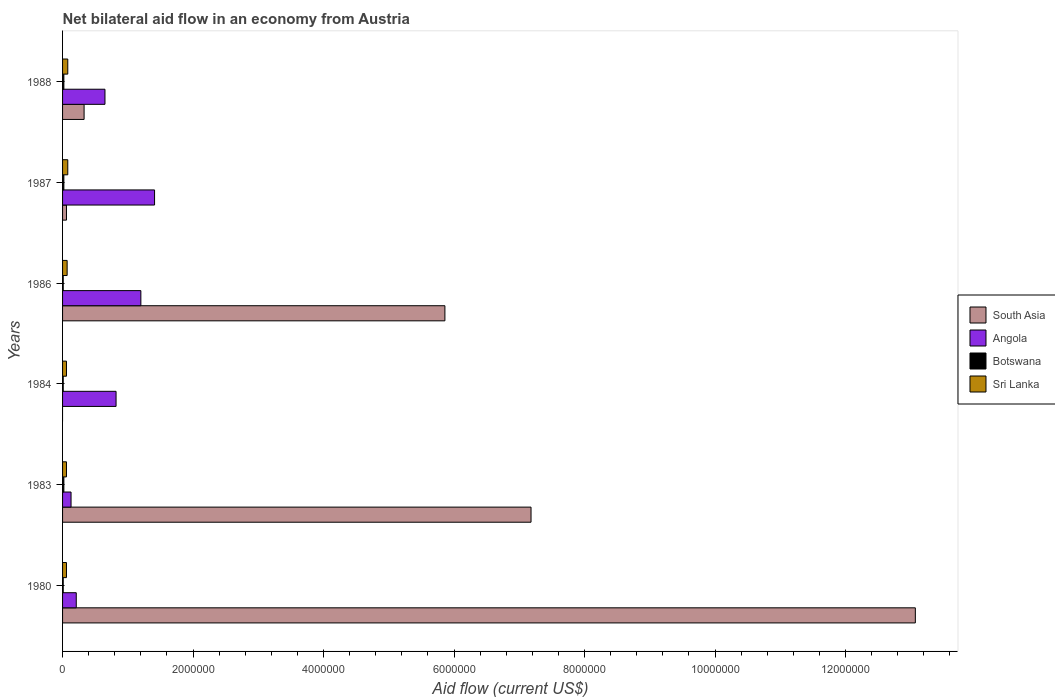How many different coloured bars are there?
Your answer should be very brief. 4. How many groups of bars are there?
Your answer should be compact. 6. Are the number of bars per tick equal to the number of legend labels?
Provide a succinct answer. No. How many bars are there on the 4th tick from the top?
Keep it short and to the point. 3. How many bars are there on the 1st tick from the bottom?
Offer a very short reply. 4. In how many cases, is the number of bars for a given year not equal to the number of legend labels?
Offer a terse response. 1. What is the net bilateral aid flow in Angola in 1984?
Provide a short and direct response. 8.20e+05. Across all years, what is the maximum net bilateral aid flow in Sri Lanka?
Provide a succinct answer. 8.00e+04. Across all years, what is the minimum net bilateral aid flow in South Asia?
Offer a terse response. 0. What is the total net bilateral aid flow in Angola in the graph?
Offer a very short reply. 4.42e+06. What is the difference between the net bilateral aid flow in South Asia in 1980 and that in 1986?
Your response must be concise. 7.21e+06. What is the difference between the net bilateral aid flow in Botswana in 1984 and the net bilateral aid flow in Angola in 1986?
Offer a terse response. -1.19e+06. What is the average net bilateral aid flow in Botswana per year?
Ensure brevity in your answer.  1.50e+04. In the year 1987, what is the difference between the net bilateral aid flow in Botswana and net bilateral aid flow in South Asia?
Provide a succinct answer. -4.00e+04. What is the ratio of the net bilateral aid flow in South Asia in 1983 to that in 1986?
Give a very brief answer. 1.23. What is the difference between the highest and the lowest net bilateral aid flow in South Asia?
Offer a terse response. 1.31e+07. Is it the case that in every year, the sum of the net bilateral aid flow in Angola and net bilateral aid flow in Botswana is greater than the sum of net bilateral aid flow in Sri Lanka and net bilateral aid flow in South Asia?
Your answer should be very brief. No. How many bars are there?
Give a very brief answer. 23. Are the values on the major ticks of X-axis written in scientific E-notation?
Provide a succinct answer. No. How are the legend labels stacked?
Provide a short and direct response. Vertical. What is the title of the graph?
Make the answer very short. Net bilateral aid flow in an economy from Austria. Does "OECD members" appear as one of the legend labels in the graph?
Give a very brief answer. No. What is the Aid flow (current US$) of South Asia in 1980?
Your answer should be very brief. 1.31e+07. What is the Aid flow (current US$) of Angola in 1980?
Your answer should be very brief. 2.10e+05. What is the Aid flow (current US$) in Sri Lanka in 1980?
Provide a short and direct response. 6.00e+04. What is the Aid flow (current US$) of South Asia in 1983?
Provide a succinct answer. 7.18e+06. What is the Aid flow (current US$) in South Asia in 1984?
Offer a very short reply. 0. What is the Aid flow (current US$) in Angola in 1984?
Your answer should be very brief. 8.20e+05. What is the Aid flow (current US$) in South Asia in 1986?
Provide a succinct answer. 5.86e+06. What is the Aid flow (current US$) in Angola in 1986?
Provide a succinct answer. 1.20e+06. What is the Aid flow (current US$) in Botswana in 1986?
Provide a succinct answer. 10000. What is the Aid flow (current US$) in South Asia in 1987?
Keep it short and to the point. 6.00e+04. What is the Aid flow (current US$) of Angola in 1987?
Your answer should be compact. 1.41e+06. What is the Aid flow (current US$) in Botswana in 1987?
Provide a succinct answer. 2.00e+04. What is the Aid flow (current US$) of Sri Lanka in 1987?
Give a very brief answer. 8.00e+04. What is the Aid flow (current US$) in South Asia in 1988?
Keep it short and to the point. 3.30e+05. What is the Aid flow (current US$) in Angola in 1988?
Keep it short and to the point. 6.50e+05. What is the Aid flow (current US$) of Botswana in 1988?
Offer a terse response. 2.00e+04. Across all years, what is the maximum Aid flow (current US$) of South Asia?
Provide a succinct answer. 1.31e+07. Across all years, what is the maximum Aid flow (current US$) of Angola?
Your answer should be very brief. 1.41e+06. Across all years, what is the maximum Aid flow (current US$) in Botswana?
Provide a succinct answer. 2.00e+04. Across all years, what is the maximum Aid flow (current US$) of Sri Lanka?
Offer a terse response. 8.00e+04. Across all years, what is the minimum Aid flow (current US$) of Botswana?
Keep it short and to the point. 10000. What is the total Aid flow (current US$) in South Asia in the graph?
Ensure brevity in your answer.  2.65e+07. What is the total Aid flow (current US$) in Angola in the graph?
Your response must be concise. 4.42e+06. What is the total Aid flow (current US$) of Botswana in the graph?
Offer a terse response. 9.00e+04. What is the difference between the Aid flow (current US$) of South Asia in 1980 and that in 1983?
Your response must be concise. 5.89e+06. What is the difference between the Aid flow (current US$) in Sri Lanka in 1980 and that in 1983?
Ensure brevity in your answer.  0. What is the difference between the Aid flow (current US$) of Angola in 1980 and that in 1984?
Offer a terse response. -6.10e+05. What is the difference between the Aid flow (current US$) in Sri Lanka in 1980 and that in 1984?
Ensure brevity in your answer.  0. What is the difference between the Aid flow (current US$) in South Asia in 1980 and that in 1986?
Provide a succinct answer. 7.21e+06. What is the difference between the Aid flow (current US$) in Angola in 1980 and that in 1986?
Your response must be concise. -9.90e+05. What is the difference between the Aid flow (current US$) of Sri Lanka in 1980 and that in 1986?
Your answer should be very brief. -10000. What is the difference between the Aid flow (current US$) of South Asia in 1980 and that in 1987?
Ensure brevity in your answer.  1.30e+07. What is the difference between the Aid flow (current US$) of Angola in 1980 and that in 1987?
Provide a succinct answer. -1.20e+06. What is the difference between the Aid flow (current US$) in Sri Lanka in 1980 and that in 1987?
Ensure brevity in your answer.  -2.00e+04. What is the difference between the Aid flow (current US$) of South Asia in 1980 and that in 1988?
Offer a terse response. 1.27e+07. What is the difference between the Aid flow (current US$) in Angola in 1980 and that in 1988?
Offer a very short reply. -4.40e+05. What is the difference between the Aid flow (current US$) of Botswana in 1980 and that in 1988?
Your answer should be very brief. -10000. What is the difference between the Aid flow (current US$) in Angola in 1983 and that in 1984?
Provide a succinct answer. -6.90e+05. What is the difference between the Aid flow (current US$) of Sri Lanka in 1983 and that in 1984?
Give a very brief answer. 0. What is the difference between the Aid flow (current US$) of South Asia in 1983 and that in 1986?
Make the answer very short. 1.32e+06. What is the difference between the Aid flow (current US$) of Angola in 1983 and that in 1986?
Offer a terse response. -1.07e+06. What is the difference between the Aid flow (current US$) in Botswana in 1983 and that in 1986?
Your response must be concise. 10000. What is the difference between the Aid flow (current US$) in Sri Lanka in 1983 and that in 1986?
Provide a short and direct response. -10000. What is the difference between the Aid flow (current US$) in South Asia in 1983 and that in 1987?
Provide a succinct answer. 7.12e+06. What is the difference between the Aid flow (current US$) of Angola in 1983 and that in 1987?
Provide a short and direct response. -1.28e+06. What is the difference between the Aid flow (current US$) of South Asia in 1983 and that in 1988?
Provide a succinct answer. 6.85e+06. What is the difference between the Aid flow (current US$) in Angola in 1983 and that in 1988?
Provide a succinct answer. -5.20e+05. What is the difference between the Aid flow (current US$) of Sri Lanka in 1983 and that in 1988?
Provide a succinct answer. -2.00e+04. What is the difference between the Aid flow (current US$) of Angola in 1984 and that in 1986?
Keep it short and to the point. -3.80e+05. What is the difference between the Aid flow (current US$) in Botswana in 1984 and that in 1986?
Give a very brief answer. 0. What is the difference between the Aid flow (current US$) in Angola in 1984 and that in 1987?
Provide a succinct answer. -5.90e+05. What is the difference between the Aid flow (current US$) in Botswana in 1984 and that in 1988?
Your answer should be compact. -10000. What is the difference between the Aid flow (current US$) of South Asia in 1986 and that in 1987?
Your answer should be very brief. 5.80e+06. What is the difference between the Aid flow (current US$) in Botswana in 1986 and that in 1987?
Ensure brevity in your answer.  -10000. What is the difference between the Aid flow (current US$) of South Asia in 1986 and that in 1988?
Offer a terse response. 5.53e+06. What is the difference between the Aid flow (current US$) of Angola in 1986 and that in 1988?
Ensure brevity in your answer.  5.50e+05. What is the difference between the Aid flow (current US$) of Botswana in 1986 and that in 1988?
Provide a succinct answer. -10000. What is the difference between the Aid flow (current US$) in Sri Lanka in 1986 and that in 1988?
Your answer should be compact. -10000. What is the difference between the Aid flow (current US$) in South Asia in 1987 and that in 1988?
Ensure brevity in your answer.  -2.70e+05. What is the difference between the Aid flow (current US$) in Angola in 1987 and that in 1988?
Your response must be concise. 7.60e+05. What is the difference between the Aid flow (current US$) of Sri Lanka in 1987 and that in 1988?
Your answer should be compact. 0. What is the difference between the Aid flow (current US$) of South Asia in 1980 and the Aid flow (current US$) of Angola in 1983?
Your response must be concise. 1.29e+07. What is the difference between the Aid flow (current US$) of South Asia in 1980 and the Aid flow (current US$) of Botswana in 1983?
Make the answer very short. 1.30e+07. What is the difference between the Aid flow (current US$) of South Asia in 1980 and the Aid flow (current US$) of Sri Lanka in 1983?
Your response must be concise. 1.30e+07. What is the difference between the Aid flow (current US$) of Angola in 1980 and the Aid flow (current US$) of Sri Lanka in 1983?
Your answer should be compact. 1.50e+05. What is the difference between the Aid flow (current US$) in South Asia in 1980 and the Aid flow (current US$) in Angola in 1984?
Your answer should be compact. 1.22e+07. What is the difference between the Aid flow (current US$) in South Asia in 1980 and the Aid flow (current US$) in Botswana in 1984?
Your answer should be very brief. 1.31e+07. What is the difference between the Aid flow (current US$) of South Asia in 1980 and the Aid flow (current US$) of Sri Lanka in 1984?
Ensure brevity in your answer.  1.30e+07. What is the difference between the Aid flow (current US$) in Angola in 1980 and the Aid flow (current US$) in Botswana in 1984?
Offer a very short reply. 2.00e+05. What is the difference between the Aid flow (current US$) of Angola in 1980 and the Aid flow (current US$) of Sri Lanka in 1984?
Provide a succinct answer. 1.50e+05. What is the difference between the Aid flow (current US$) of Botswana in 1980 and the Aid flow (current US$) of Sri Lanka in 1984?
Keep it short and to the point. -5.00e+04. What is the difference between the Aid flow (current US$) of South Asia in 1980 and the Aid flow (current US$) of Angola in 1986?
Provide a succinct answer. 1.19e+07. What is the difference between the Aid flow (current US$) in South Asia in 1980 and the Aid flow (current US$) in Botswana in 1986?
Give a very brief answer. 1.31e+07. What is the difference between the Aid flow (current US$) in South Asia in 1980 and the Aid flow (current US$) in Sri Lanka in 1986?
Provide a succinct answer. 1.30e+07. What is the difference between the Aid flow (current US$) of Botswana in 1980 and the Aid flow (current US$) of Sri Lanka in 1986?
Your response must be concise. -6.00e+04. What is the difference between the Aid flow (current US$) in South Asia in 1980 and the Aid flow (current US$) in Angola in 1987?
Your answer should be very brief. 1.17e+07. What is the difference between the Aid flow (current US$) of South Asia in 1980 and the Aid flow (current US$) of Botswana in 1987?
Give a very brief answer. 1.30e+07. What is the difference between the Aid flow (current US$) in South Asia in 1980 and the Aid flow (current US$) in Sri Lanka in 1987?
Provide a short and direct response. 1.30e+07. What is the difference between the Aid flow (current US$) of Angola in 1980 and the Aid flow (current US$) of Sri Lanka in 1987?
Keep it short and to the point. 1.30e+05. What is the difference between the Aid flow (current US$) in South Asia in 1980 and the Aid flow (current US$) in Angola in 1988?
Offer a terse response. 1.24e+07. What is the difference between the Aid flow (current US$) in South Asia in 1980 and the Aid flow (current US$) in Botswana in 1988?
Offer a very short reply. 1.30e+07. What is the difference between the Aid flow (current US$) of South Asia in 1980 and the Aid flow (current US$) of Sri Lanka in 1988?
Provide a succinct answer. 1.30e+07. What is the difference between the Aid flow (current US$) in Angola in 1980 and the Aid flow (current US$) in Botswana in 1988?
Provide a short and direct response. 1.90e+05. What is the difference between the Aid flow (current US$) in South Asia in 1983 and the Aid flow (current US$) in Angola in 1984?
Keep it short and to the point. 6.36e+06. What is the difference between the Aid flow (current US$) of South Asia in 1983 and the Aid flow (current US$) of Botswana in 1984?
Your answer should be very brief. 7.17e+06. What is the difference between the Aid flow (current US$) of South Asia in 1983 and the Aid flow (current US$) of Sri Lanka in 1984?
Provide a succinct answer. 7.12e+06. What is the difference between the Aid flow (current US$) of Angola in 1983 and the Aid flow (current US$) of Botswana in 1984?
Provide a short and direct response. 1.20e+05. What is the difference between the Aid flow (current US$) of Angola in 1983 and the Aid flow (current US$) of Sri Lanka in 1984?
Give a very brief answer. 7.00e+04. What is the difference between the Aid flow (current US$) of Botswana in 1983 and the Aid flow (current US$) of Sri Lanka in 1984?
Keep it short and to the point. -4.00e+04. What is the difference between the Aid flow (current US$) of South Asia in 1983 and the Aid flow (current US$) of Angola in 1986?
Provide a short and direct response. 5.98e+06. What is the difference between the Aid flow (current US$) in South Asia in 1983 and the Aid flow (current US$) in Botswana in 1986?
Keep it short and to the point. 7.17e+06. What is the difference between the Aid flow (current US$) in South Asia in 1983 and the Aid flow (current US$) in Sri Lanka in 1986?
Provide a short and direct response. 7.11e+06. What is the difference between the Aid flow (current US$) of Angola in 1983 and the Aid flow (current US$) of Sri Lanka in 1986?
Ensure brevity in your answer.  6.00e+04. What is the difference between the Aid flow (current US$) of Botswana in 1983 and the Aid flow (current US$) of Sri Lanka in 1986?
Ensure brevity in your answer.  -5.00e+04. What is the difference between the Aid flow (current US$) of South Asia in 1983 and the Aid flow (current US$) of Angola in 1987?
Provide a short and direct response. 5.77e+06. What is the difference between the Aid flow (current US$) of South Asia in 1983 and the Aid flow (current US$) of Botswana in 1987?
Your response must be concise. 7.16e+06. What is the difference between the Aid flow (current US$) of South Asia in 1983 and the Aid flow (current US$) of Sri Lanka in 1987?
Provide a succinct answer. 7.10e+06. What is the difference between the Aid flow (current US$) of South Asia in 1983 and the Aid flow (current US$) of Angola in 1988?
Provide a short and direct response. 6.53e+06. What is the difference between the Aid flow (current US$) of South Asia in 1983 and the Aid flow (current US$) of Botswana in 1988?
Keep it short and to the point. 7.16e+06. What is the difference between the Aid flow (current US$) of South Asia in 1983 and the Aid flow (current US$) of Sri Lanka in 1988?
Your answer should be very brief. 7.10e+06. What is the difference between the Aid flow (current US$) of Angola in 1983 and the Aid flow (current US$) of Sri Lanka in 1988?
Your response must be concise. 5.00e+04. What is the difference between the Aid flow (current US$) of Angola in 1984 and the Aid flow (current US$) of Botswana in 1986?
Offer a terse response. 8.10e+05. What is the difference between the Aid flow (current US$) of Angola in 1984 and the Aid flow (current US$) of Sri Lanka in 1986?
Your answer should be very brief. 7.50e+05. What is the difference between the Aid flow (current US$) in Angola in 1984 and the Aid flow (current US$) in Botswana in 1987?
Keep it short and to the point. 8.00e+05. What is the difference between the Aid flow (current US$) of Angola in 1984 and the Aid flow (current US$) of Sri Lanka in 1987?
Provide a succinct answer. 7.40e+05. What is the difference between the Aid flow (current US$) in Botswana in 1984 and the Aid flow (current US$) in Sri Lanka in 1987?
Keep it short and to the point. -7.00e+04. What is the difference between the Aid flow (current US$) in Angola in 1984 and the Aid flow (current US$) in Sri Lanka in 1988?
Provide a short and direct response. 7.40e+05. What is the difference between the Aid flow (current US$) in South Asia in 1986 and the Aid flow (current US$) in Angola in 1987?
Provide a short and direct response. 4.45e+06. What is the difference between the Aid flow (current US$) in South Asia in 1986 and the Aid flow (current US$) in Botswana in 1987?
Your answer should be compact. 5.84e+06. What is the difference between the Aid flow (current US$) in South Asia in 1986 and the Aid flow (current US$) in Sri Lanka in 1987?
Provide a short and direct response. 5.78e+06. What is the difference between the Aid flow (current US$) of Angola in 1986 and the Aid flow (current US$) of Botswana in 1987?
Keep it short and to the point. 1.18e+06. What is the difference between the Aid flow (current US$) in Angola in 1986 and the Aid flow (current US$) in Sri Lanka in 1987?
Provide a succinct answer. 1.12e+06. What is the difference between the Aid flow (current US$) in Botswana in 1986 and the Aid flow (current US$) in Sri Lanka in 1987?
Offer a very short reply. -7.00e+04. What is the difference between the Aid flow (current US$) of South Asia in 1986 and the Aid flow (current US$) of Angola in 1988?
Keep it short and to the point. 5.21e+06. What is the difference between the Aid flow (current US$) in South Asia in 1986 and the Aid flow (current US$) in Botswana in 1988?
Give a very brief answer. 5.84e+06. What is the difference between the Aid flow (current US$) of South Asia in 1986 and the Aid flow (current US$) of Sri Lanka in 1988?
Make the answer very short. 5.78e+06. What is the difference between the Aid flow (current US$) of Angola in 1986 and the Aid flow (current US$) of Botswana in 1988?
Make the answer very short. 1.18e+06. What is the difference between the Aid flow (current US$) of Angola in 1986 and the Aid flow (current US$) of Sri Lanka in 1988?
Your answer should be very brief. 1.12e+06. What is the difference between the Aid flow (current US$) of South Asia in 1987 and the Aid flow (current US$) of Angola in 1988?
Offer a terse response. -5.90e+05. What is the difference between the Aid flow (current US$) of Angola in 1987 and the Aid flow (current US$) of Botswana in 1988?
Your response must be concise. 1.39e+06. What is the difference between the Aid flow (current US$) of Angola in 1987 and the Aid flow (current US$) of Sri Lanka in 1988?
Give a very brief answer. 1.33e+06. What is the average Aid flow (current US$) in South Asia per year?
Provide a short and direct response. 4.42e+06. What is the average Aid flow (current US$) in Angola per year?
Your answer should be compact. 7.37e+05. What is the average Aid flow (current US$) of Botswana per year?
Ensure brevity in your answer.  1.50e+04. What is the average Aid flow (current US$) in Sri Lanka per year?
Your answer should be compact. 6.83e+04. In the year 1980, what is the difference between the Aid flow (current US$) in South Asia and Aid flow (current US$) in Angola?
Your answer should be compact. 1.29e+07. In the year 1980, what is the difference between the Aid flow (current US$) in South Asia and Aid flow (current US$) in Botswana?
Provide a succinct answer. 1.31e+07. In the year 1980, what is the difference between the Aid flow (current US$) of South Asia and Aid flow (current US$) of Sri Lanka?
Make the answer very short. 1.30e+07. In the year 1980, what is the difference between the Aid flow (current US$) in Angola and Aid flow (current US$) in Botswana?
Provide a succinct answer. 2.00e+05. In the year 1980, what is the difference between the Aid flow (current US$) of Angola and Aid flow (current US$) of Sri Lanka?
Your response must be concise. 1.50e+05. In the year 1983, what is the difference between the Aid flow (current US$) in South Asia and Aid flow (current US$) in Angola?
Make the answer very short. 7.05e+06. In the year 1983, what is the difference between the Aid flow (current US$) of South Asia and Aid flow (current US$) of Botswana?
Provide a short and direct response. 7.16e+06. In the year 1983, what is the difference between the Aid flow (current US$) of South Asia and Aid flow (current US$) of Sri Lanka?
Keep it short and to the point. 7.12e+06. In the year 1983, what is the difference between the Aid flow (current US$) in Angola and Aid flow (current US$) in Sri Lanka?
Your answer should be compact. 7.00e+04. In the year 1983, what is the difference between the Aid flow (current US$) of Botswana and Aid flow (current US$) of Sri Lanka?
Your answer should be very brief. -4.00e+04. In the year 1984, what is the difference between the Aid flow (current US$) of Angola and Aid flow (current US$) of Botswana?
Offer a terse response. 8.10e+05. In the year 1984, what is the difference between the Aid flow (current US$) in Angola and Aid flow (current US$) in Sri Lanka?
Give a very brief answer. 7.60e+05. In the year 1986, what is the difference between the Aid flow (current US$) of South Asia and Aid flow (current US$) of Angola?
Provide a short and direct response. 4.66e+06. In the year 1986, what is the difference between the Aid flow (current US$) in South Asia and Aid flow (current US$) in Botswana?
Provide a short and direct response. 5.85e+06. In the year 1986, what is the difference between the Aid flow (current US$) of South Asia and Aid flow (current US$) of Sri Lanka?
Your answer should be very brief. 5.79e+06. In the year 1986, what is the difference between the Aid flow (current US$) in Angola and Aid flow (current US$) in Botswana?
Make the answer very short. 1.19e+06. In the year 1986, what is the difference between the Aid flow (current US$) of Angola and Aid flow (current US$) of Sri Lanka?
Offer a very short reply. 1.13e+06. In the year 1987, what is the difference between the Aid flow (current US$) in South Asia and Aid flow (current US$) in Angola?
Your answer should be compact. -1.35e+06. In the year 1987, what is the difference between the Aid flow (current US$) in Angola and Aid flow (current US$) in Botswana?
Your answer should be very brief. 1.39e+06. In the year 1987, what is the difference between the Aid flow (current US$) of Angola and Aid flow (current US$) of Sri Lanka?
Ensure brevity in your answer.  1.33e+06. In the year 1987, what is the difference between the Aid flow (current US$) in Botswana and Aid flow (current US$) in Sri Lanka?
Your answer should be compact. -6.00e+04. In the year 1988, what is the difference between the Aid flow (current US$) of South Asia and Aid flow (current US$) of Angola?
Keep it short and to the point. -3.20e+05. In the year 1988, what is the difference between the Aid flow (current US$) in Angola and Aid flow (current US$) in Botswana?
Keep it short and to the point. 6.30e+05. In the year 1988, what is the difference between the Aid flow (current US$) in Angola and Aid flow (current US$) in Sri Lanka?
Keep it short and to the point. 5.70e+05. What is the ratio of the Aid flow (current US$) of South Asia in 1980 to that in 1983?
Offer a very short reply. 1.82. What is the ratio of the Aid flow (current US$) of Angola in 1980 to that in 1983?
Ensure brevity in your answer.  1.62. What is the ratio of the Aid flow (current US$) in Angola in 1980 to that in 1984?
Keep it short and to the point. 0.26. What is the ratio of the Aid flow (current US$) of Sri Lanka in 1980 to that in 1984?
Offer a terse response. 1. What is the ratio of the Aid flow (current US$) in South Asia in 1980 to that in 1986?
Offer a terse response. 2.23. What is the ratio of the Aid flow (current US$) in Angola in 1980 to that in 1986?
Give a very brief answer. 0.17. What is the ratio of the Aid flow (current US$) of Sri Lanka in 1980 to that in 1986?
Your answer should be very brief. 0.86. What is the ratio of the Aid flow (current US$) of South Asia in 1980 to that in 1987?
Offer a very short reply. 217.83. What is the ratio of the Aid flow (current US$) in Angola in 1980 to that in 1987?
Provide a succinct answer. 0.15. What is the ratio of the Aid flow (current US$) of South Asia in 1980 to that in 1988?
Ensure brevity in your answer.  39.61. What is the ratio of the Aid flow (current US$) in Angola in 1980 to that in 1988?
Provide a short and direct response. 0.32. What is the ratio of the Aid flow (current US$) of Botswana in 1980 to that in 1988?
Keep it short and to the point. 0.5. What is the ratio of the Aid flow (current US$) in Sri Lanka in 1980 to that in 1988?
Offer a terse response. 0.75. What is the ratio of the Aid flow (current US$) of Angola in 1983 to that in 1984?
Keep it short and to the point. 0.16. What is the ratio of the Aid flow (current US$) of Botswana in 1983 to that in 1984?
Offer a terse response. 2. What is the ratio of the Aid flow (current US$) in Sri Lanka in 1983 to that in 1984?
Give a very brief answer. 1. What is the ratio of the Aid flow (current US$) of South Asia in 1983 to that in 1986?
Your answer should be very brief. 1.23. What is the ratio of the Aid flow (current US$) of Angola in 1983 to that in 1986?
Your response must be concise. 0.11. What is the ratio of the Aid flow (current US$) of Sri Lanka in 1983 to that in 1986?
Make the answer very short. 0.86. What is the ratio of the Aid flow (current US$) of South Asia in 1983 to that in 1987?
Keep it short and to the point. 119.67. What is the ratio of the Aid flow (current US$) of Angola in 1983 to that in 1987?
Your answer should be very brief. 0.09. What is the ratio of the Aid flow (current US$) in Sri Lanka in 1983 to that in 1987?
Your response must be concise. 0.75. What is the ratio of the Aid flow (current US$) in South Asia in 1983 to that in 1988?
Make the answer very short. 21.76. What is the ratio of the Aid flow (current US$) in Angola in 1984 to that in 1986?
Keep it short and to the point. 0.68. What is the ratio of the Aid flow (current US$) of Botswana in 1984 to that in 1986?
Keep it short and to the point. 1. What is the ratio of the Aid flow (current US$) of Angola in 1984 to that in 1987?
Offer a very short reply. 0.58. What is the ratio of the Aid flow (current US$) of Botswana in 1984 to that in 1987?
Your response must be concise. 0.5. What is the ratio of the Aid flow (current US$) in Sri Lanka in 1984 to that in 1987?
Give a very brief answer. 0.75. What is the ratio of the Aid flow (current US$) of Angola in 1984 to that in 1988?
Give a very brief answer. 1.26. What is the ratio of the Aid flow (current US$) of Sri Lanka in 1984 to that in 1988?
Offer a terse response. 0.75. What is the ratio of the Aid flow (current US$) in South Asia in 1986 to that in 1987?
Provide a short and direct response. 97.67. What is the ratio of the Aid flow (current US$) of Angola in 1986 to that in 1987?
Keep it short and to the point. 0.85. What is the ratio of the Aid flow (current US$) of Sri Lanka in 1986 to that in 1987?
Your response must be concise. 0.88. What is the ratio of the Aid flow (current US$) in South Asia in 1986 to that in 1988?
Keep it short and to the point. 17.76. What is the ratio of the Aid flow (current US$) of Angola in 1986 to that in 1988?
Your answer should be very brief. 1.85. What is the ratio of the Aid flow (current US$) of Botswana in 1986 to that in 1988?
Your response must be concise. 0.5. What is the ratio of the Aid flow (current US$) in South Asia in 1987 to that in 1988?
Your answer should be very brief. 0.18. What is the ratio of the Aid flow (current US$) in Angola in 1987 to that in 1988?
Ensure brevity in your answer.  2.17. What is the difference between the highest and the second highest Aid flow (current US$) in South Asia?
Your answer should be very brief. 5.89e+06. What is the difference between the highest and the second highest Aid flow (current US$) in Sri Lanka?
Provide a succinct answer. 0. What is the difference between the highest and the lowest Aid flow (current US$) in South Asia?
Your response must be concise. 1.31e+07. What is the difference between the highest and the lowest Aid flow (current US$) in Angola?
Make the answer very short. 1.28e+06. 